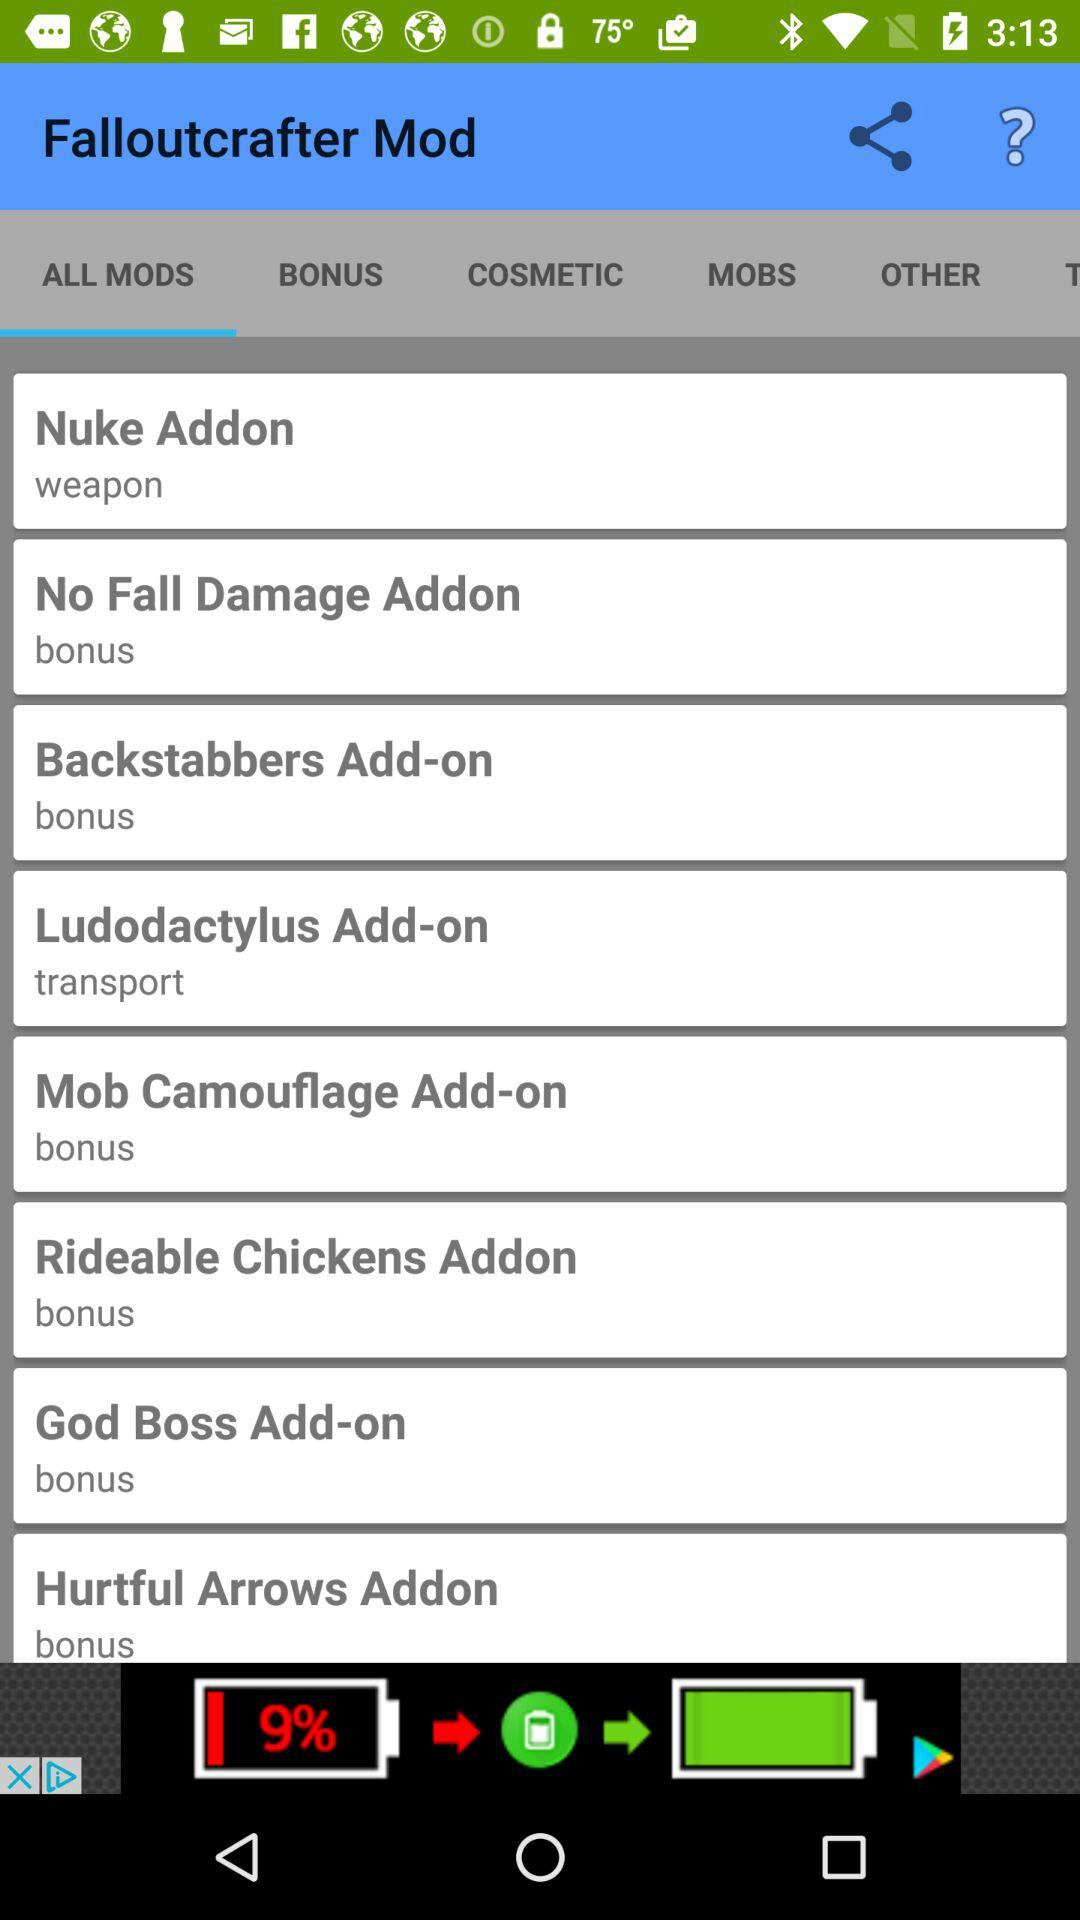Which tab is selected? The selected tab is "ALL MODS". 